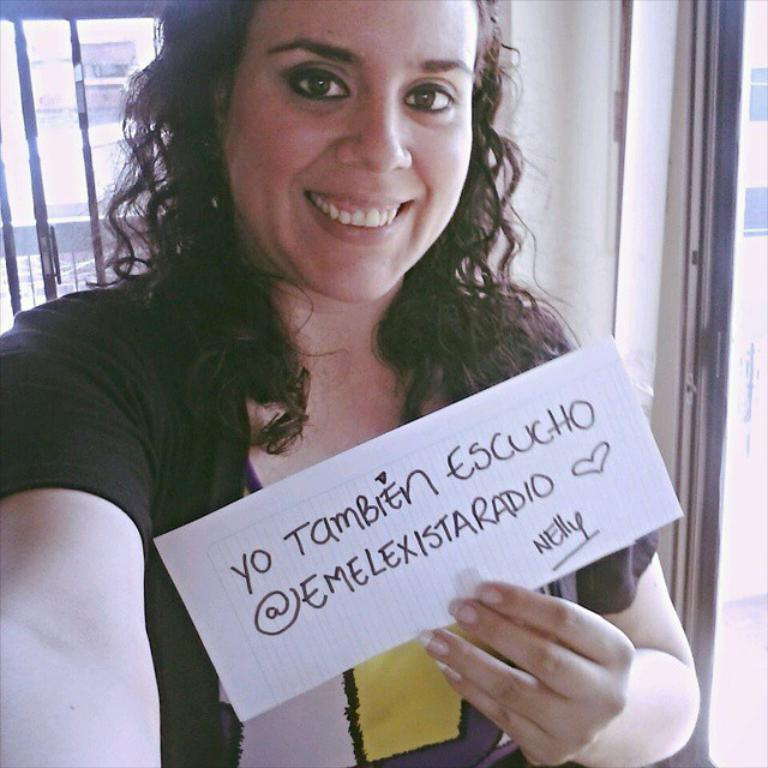Who is the main subject in the foreground of the picture? There is a woman in the foreground of the picture. What is the woman holding in the image? The woman is holding a paper. What architectural feature can be seen in the image? There is a window and a wall in the image. What is visible in the background of the image? There is a building in the background of the image. What type of river can be seen flowing through the heart of the woman in the image? There is no river or heart visible in the image; it features a woman holding a paper in front of a building. 